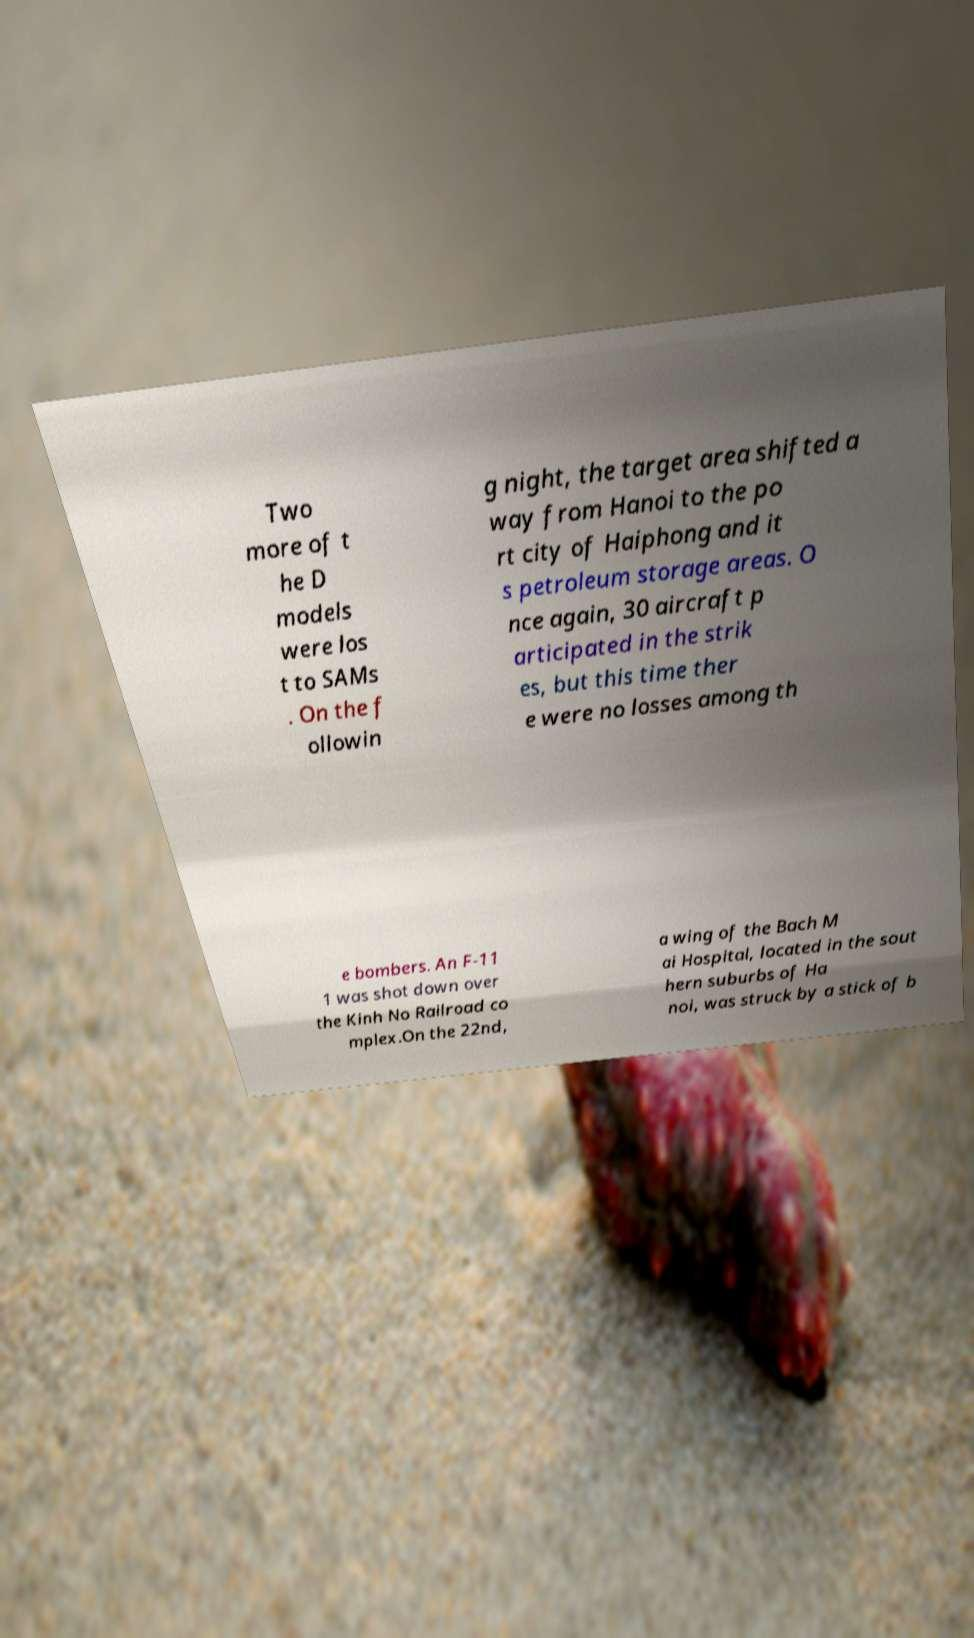For documentation purposes, I need the text within this image transcribed. Could you provide that? Two more of t he D models were los t to SAMs . On the f ollowin g night, the target area shifted a way from Hanoi to the po rt city of Haiphong and it s petroleum storage areas. O nce again, 30 aircraft p articipated in the strik es, but this time ther e were no losses among th e bombers. An F-11 1 was shot down over the Kinh No Railroad co mplex.On the 22nd, a wing of the Bach M ai Hospital, located in the sout hern suburbs of Ha noi, was struck by a stick of b 